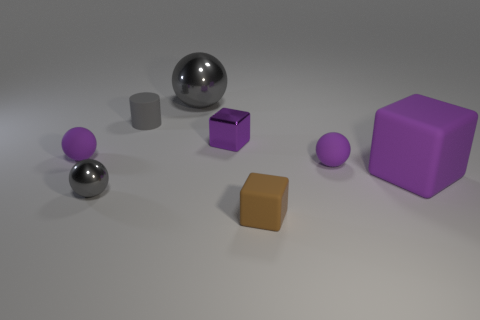How many other things are the same size as the purple metallic block?
Ensure brevity in your answer.  5. Do the tiny matte thing left of the tiny gray shiny object and the large rubber thing have the same shape?
Make the answer very short. No. There is another metal object that is the same shape as the large gray metallic thing; what color is it?
Provide a short and direct response. Gray. Are there any other things that have the same shape as the gray matte object?
Keep it short and to the point. No. Are there an equal number of small rubber blocks that are behind the tiny rubber cylinder and large purple matte objects?
Ensure brevity in your answer.  No. What number of purple things are both to the right of the small matte cylinder and behind the large purple cube?
Your answer should be compact. 2. What is the size of the other gray shiny object that is the same shape as the large metal object?
Keep it short and to the point. Small. How many big purple cubes have the same material as the tiny gray ball?
Offer a terse response. 0. Are there fewer cylinders right of the large purple cube than small blue metal balls?
Ensure brevity in your answer.  No. How many large cyan metal blocks are there?
Give a very brief answer. 0. 